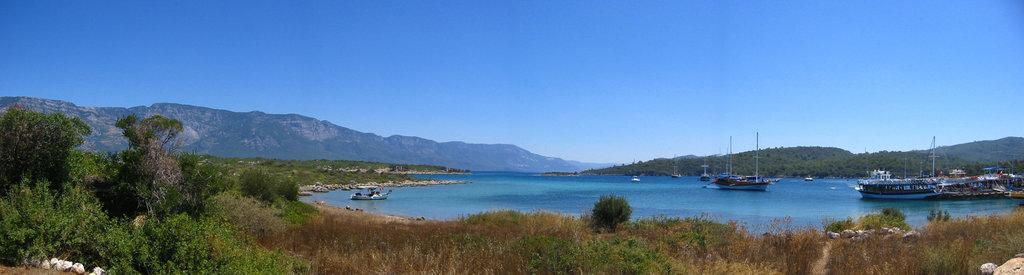What is on the water in the image? There are boats on the water in the image. What type of natural elements can be seen in the image? Trees and plants are visible in the image. What other objects can be found in the image? There are rocks in the image. What is visible in the distance in the image? In the background of the image, there are mountains. Where are the tomatoes growing in the image? There are no tomatoes present in the image. What type of wood is used to build the boats in the image? There is no information about the boats' construction materials in the image. 